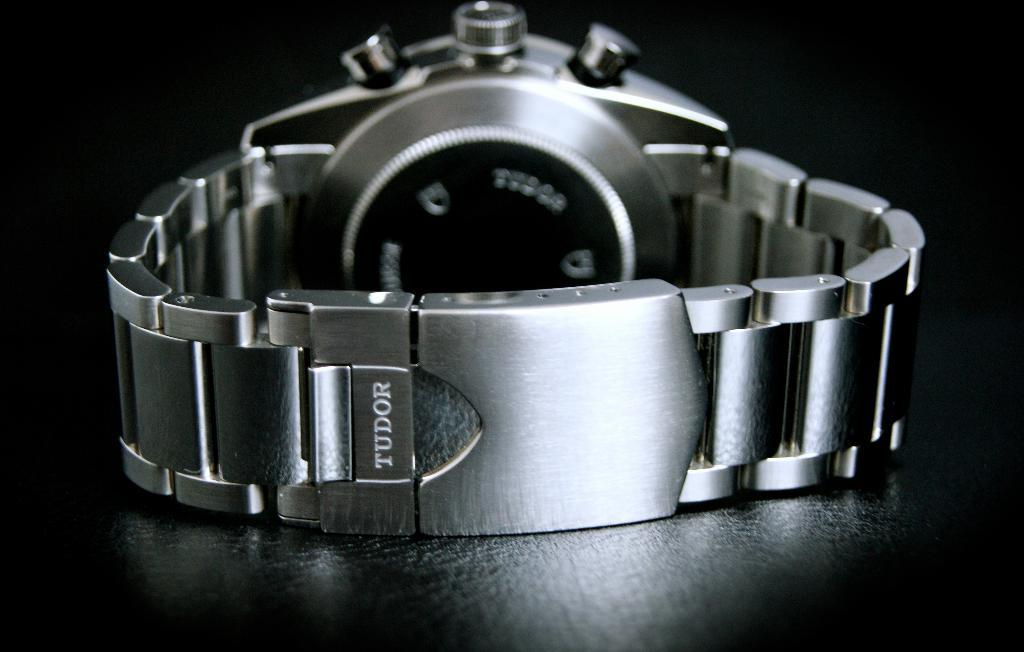Provide a one-sentence caption for the provided image. A Tudor brand watch is displayed, prominently showing the wristband. 